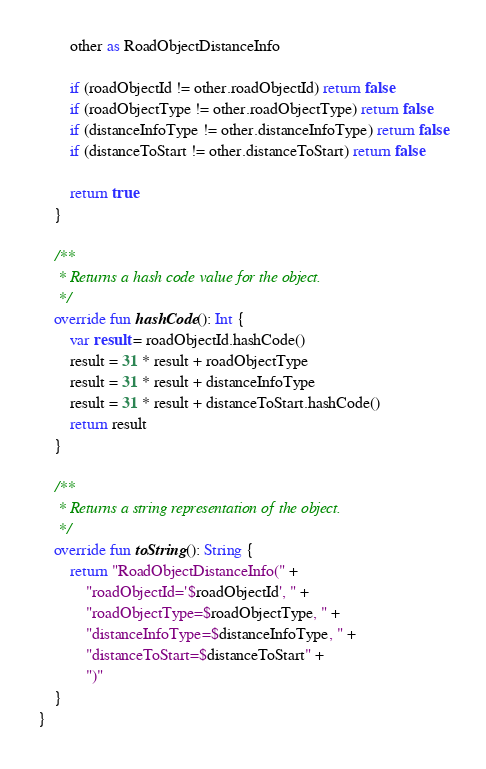<code> <loc_0><loc_0><loc_500><loc_500><_Kotlin_>
        other as RoadObjectDistanceInfo

        if (roadObjectId != other.roadObjectId) return false
        if (roadObjectType != other.roadObjectType) return false
        if (distanceInfoType != other.distanceInfoType) return false
        if (distanceToStart != other.distanceToStart) return false

        return true
    }

    /**
     * Returns a hash code value for the object.
     */
    override fun hashCode(): Int {
        var result = roadObjectId.hashCode()
        result = 31 * result + roadObjectType
        result = 31 * result + distanceInfoType
        result = 31 * result + distanceToStart.hashCode()
        return result
    }

    /**
     * Returns a string representation of the object.
     */
    override fun toString(): String {
        return "RoadObjectDistanceInfo(" +
            "roadObjectId='$roadObjectId', " +
            "roadObjectType=$roadObjectType, " +
            "distanceInfoType=$distanceInfoType, " +
            "distanceToStart=$distanceToStart" +
            ")"
    }
}
</code> 